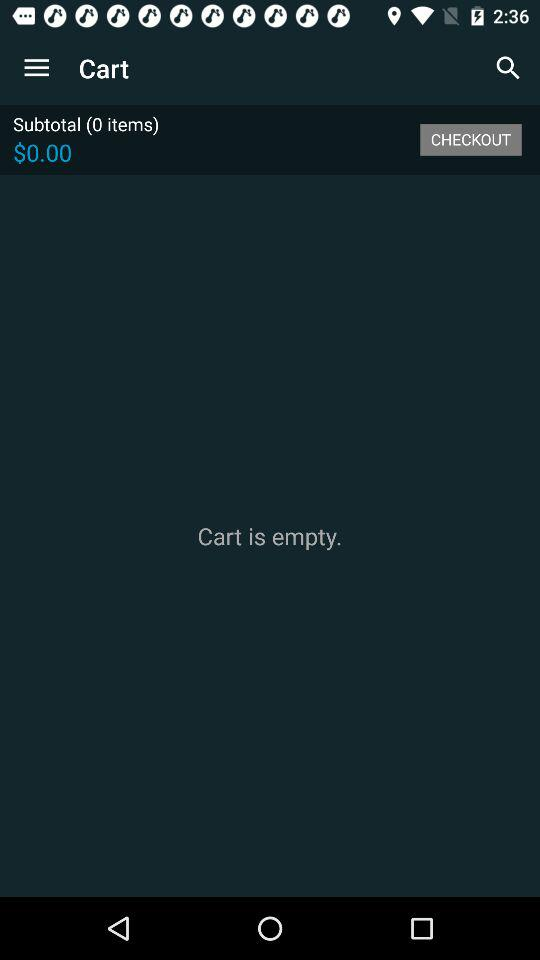How many items are in the cart?
Answer the question using a single word or phrase. 0 